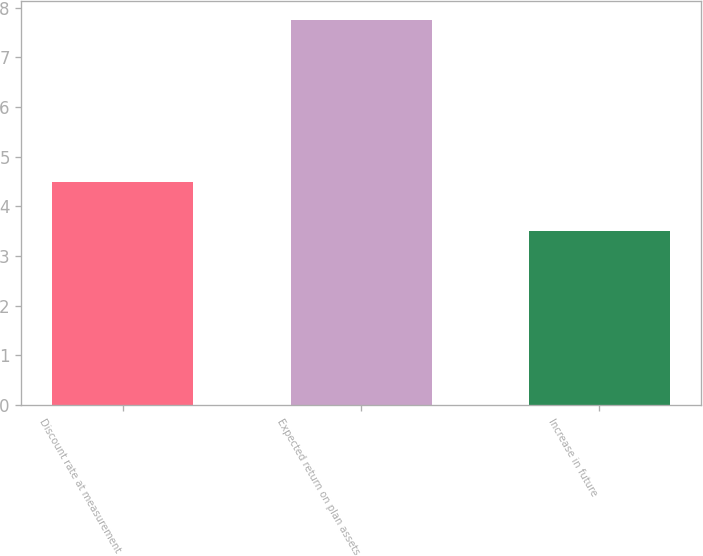Convert chart to OTSL. <chart><loc_0><loc_0><loc_500><loc_500><bar_chart><fcel>Discount rate at measurement<fcel>Expected return on plan assets<fcel>Increase in future<nl><fcel>4.5<fcel>7.75<fcel>3.5<nl></chart> 